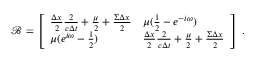<formula> <loc_0><loc_0><loc_500><loc_500>\mathcal { B } = \left [ \begin{array} { l l } { \frac { \Delta x } { 2 } \frac { 2 } { c \Delta t } + \frac { \mu } { 2 } + \frac { \Sigma \Delta x } { 2 } } & { \mu ( \frac { 1 } { 2 } - e ^ { - i \omega } ) } \\ { \mu ( e ^ { i \omega } - \frac { 1 } { 2 } ) } & { \frac { \Delta x } { 2 } \frac { 2 } { c \Delta t } + \frac { \mu } { 2 } + \frac { \Sigma \Delta x } { 2 } } \end{array} \right ] \, .</formula> 